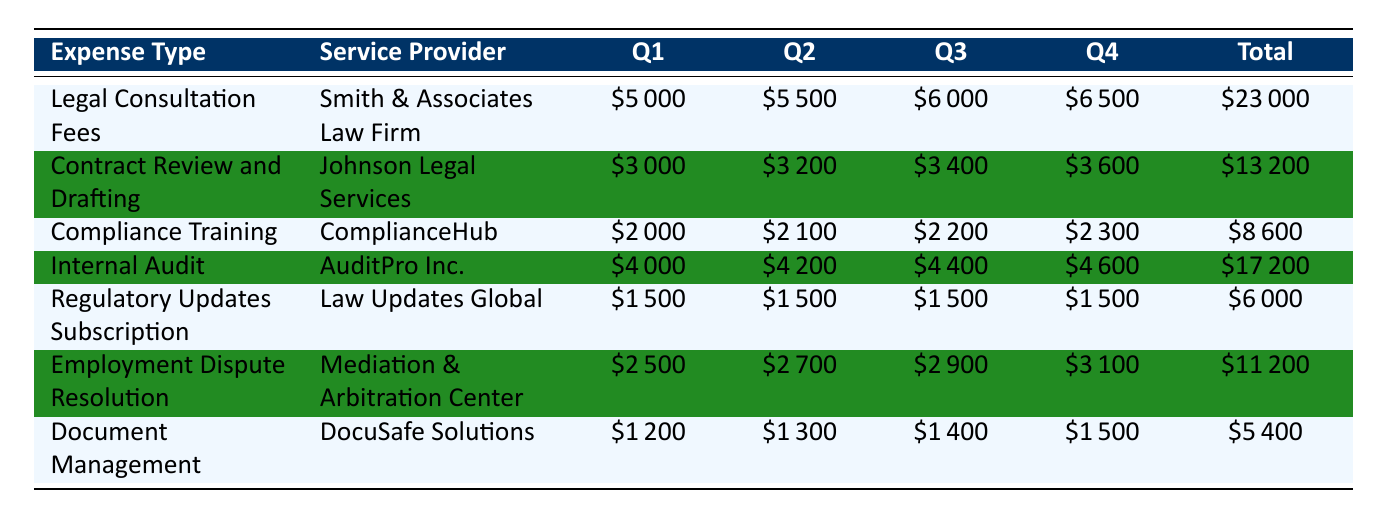What is the total expense for Legal Consultation Fees? The total expense for Legal Consultation Fees is listed in the table under the "Total" column for that expense type, which is 23,000.
Answer: 23000 Which service provider charged the least amount for their services? Looking at the "Total" column for all service providers, DocuSafe Solutions has the lowest total expense of 5,400.
Answer: 5400 What was the total amount spent on Compliance Training throughout the year? The "Total" column for Compliance Training shows the expense amount, which is 8,600.
Answer: 8600 How much more was spent on Internal Audit than on Document Management? The total for Internal Audit is 17,200 and for Document Management it is 5,400. Subtracting these gives 17,200 - 5,400 = 11,800.
Answer: 11800 Was there any increase in costs from Quarter 1 to Quarter 4 for Contract Review and Drafting? The expense in Quarter 1 for Contract Review and Drafting is 3,000 and in Quarter 4, it is 3,600. Since 3,600 is greater than 3,000, it indicates an increase.
Answer: Yes What is the average expense per quarter for Employment Dispute Resolution? Total expense for Employment Dispute Resolution is 11,200. Dividing by 4 quarters gives 11,200 / 4 = 2,800 as the average expense per quarter.
Answer: 2800 What is the combined total expense for Regulatory Updates Subscription and Document Management? The total for Regulatory Updates Subscription is 6,000 and Document Management is 5,400. Adding these gives 6,000 + 5,400 = 11,400.
Answer: 11400 Which expense type incurred the highest costs in Quarter 3? In Quarter 3, the expenses were: Legal Consultation Fees (6,000), Contract Review and Drafting (3,400), Compliance Training (2,200), Internal Audit (4,400), Regulatory Updates Subscription (1,500), Employment Dispute Resolution (2,900), and Document Management (1,400). The highest is from Legal Consultation Fees at 6,000.
Answer: Legal Consultation Fees Is the total expense for Compliance Training less than the total for Employment Dispute Resolution? The total for Compliance Training is 8,600 and for Employment Dispute Resolution, it is 11,200. Since 8,600 is less than 11,200, the statement is true.
Answer: Yes 